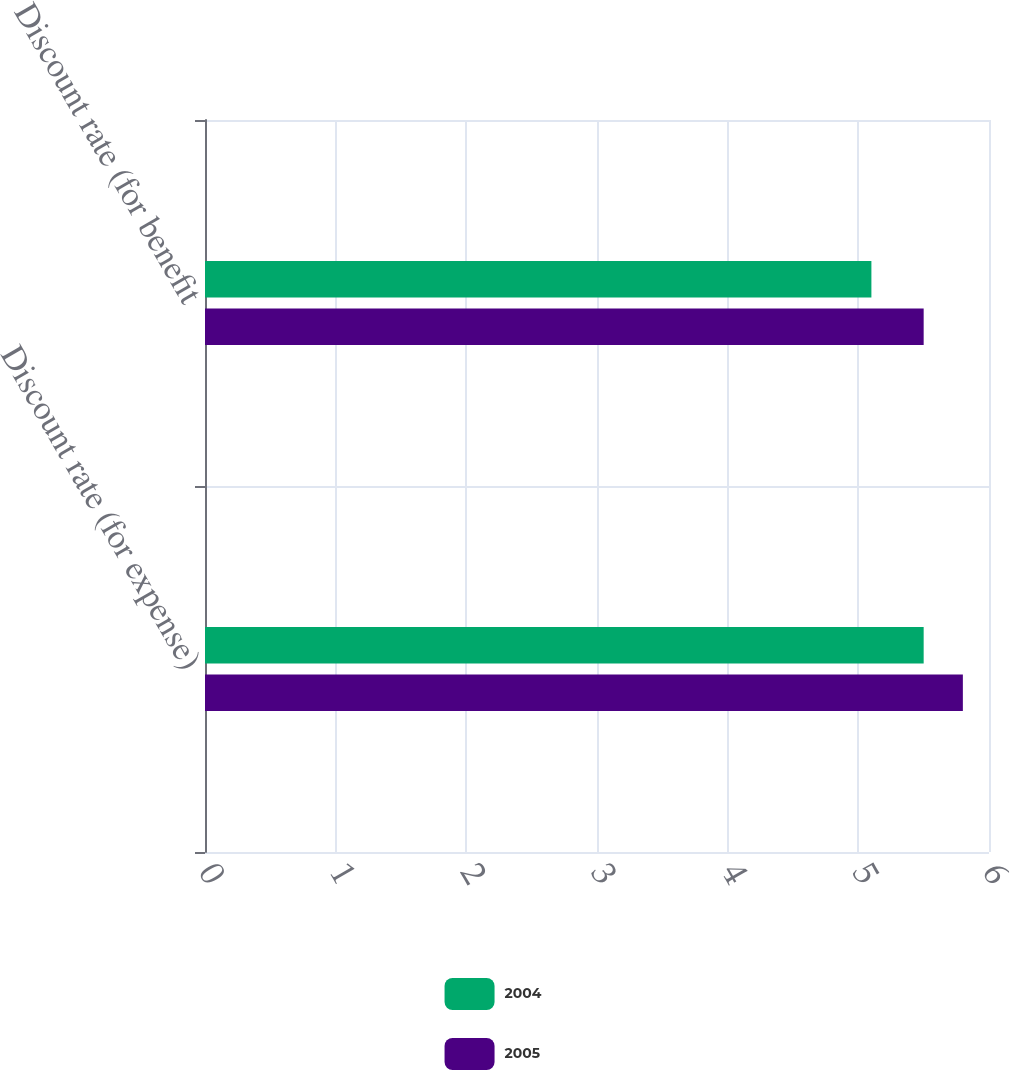Convert chart. <chart><loc_0><loc_0><loc_500><loc_500><stacked_bar_chart><ecel><fcel>Discount rate (for expense)<fcel>Discount rate (for benefit<nl><fcel>2004<fcel>5.5<fcel>5.1<nl><fcel>2005<fcel>5.8<fcel>5.5<nl></chart> 